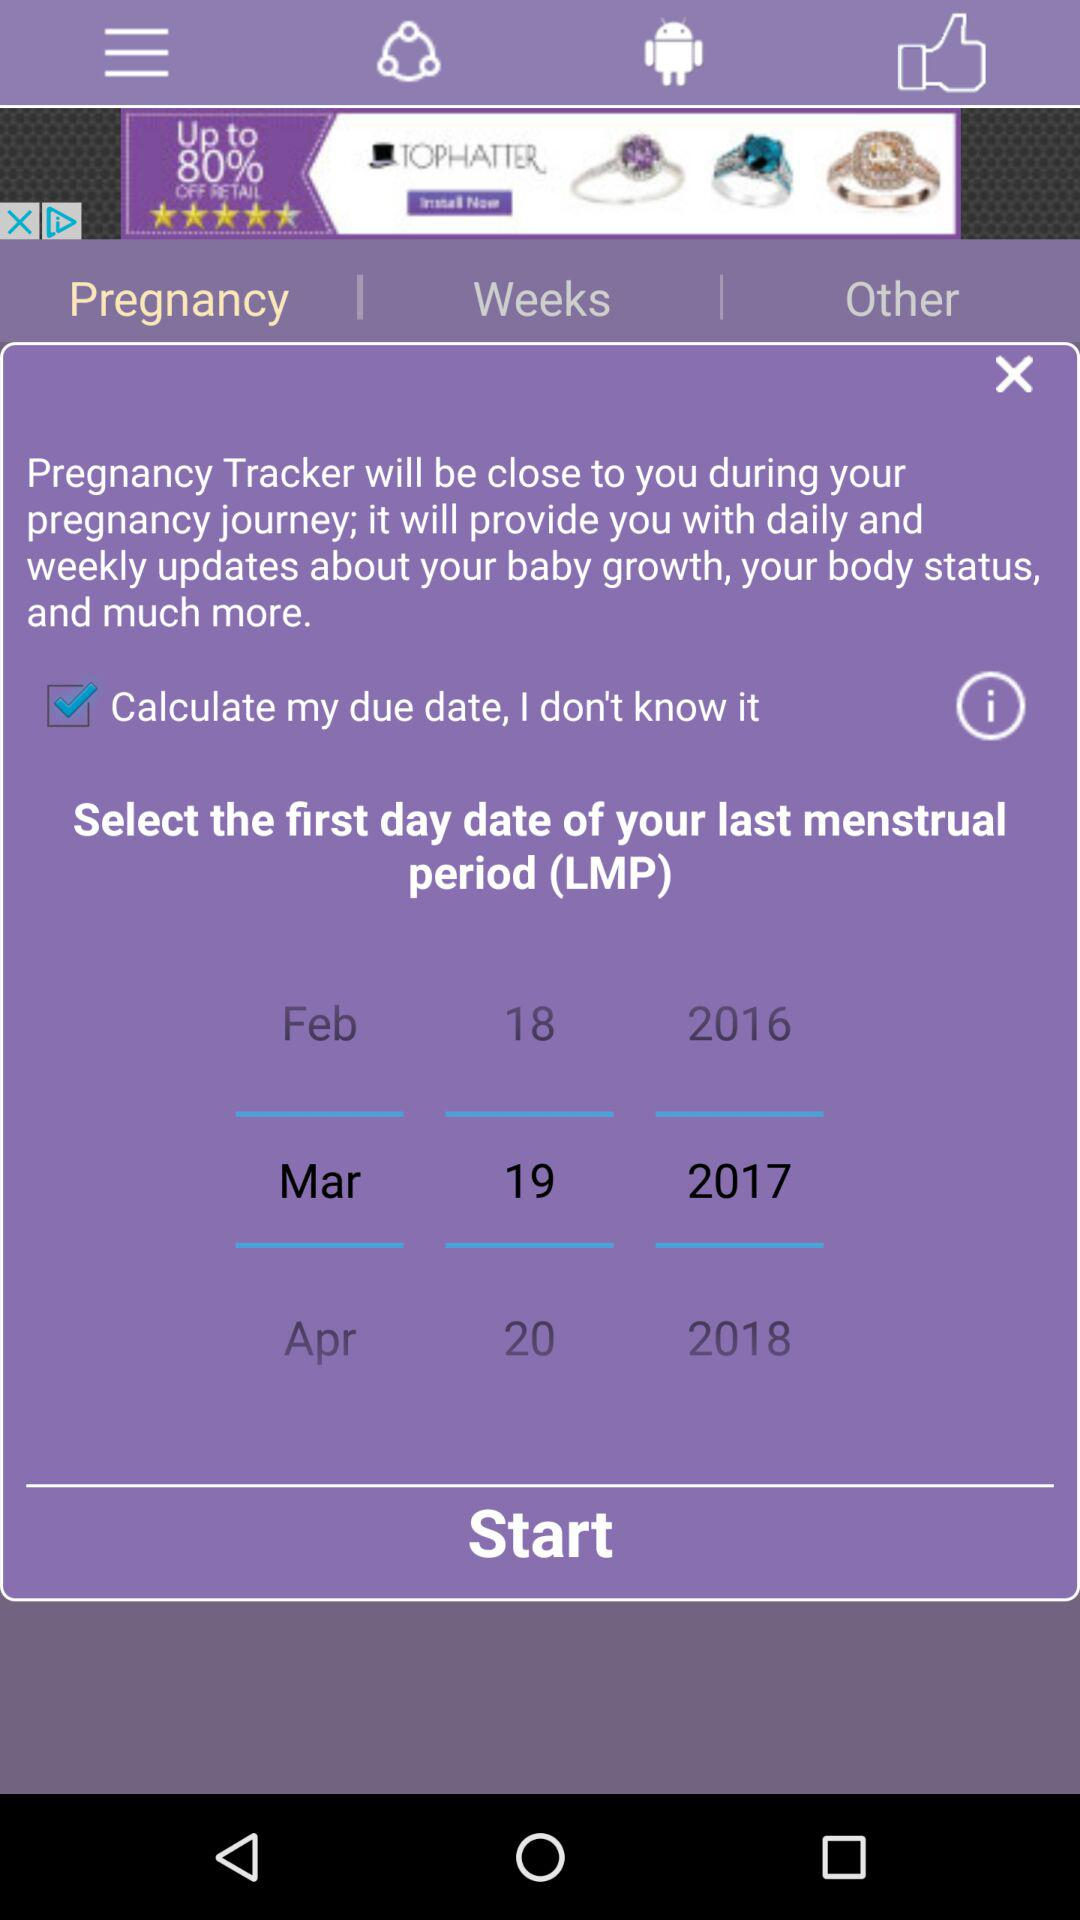What is the rating? The rating is 4.5 stars. 